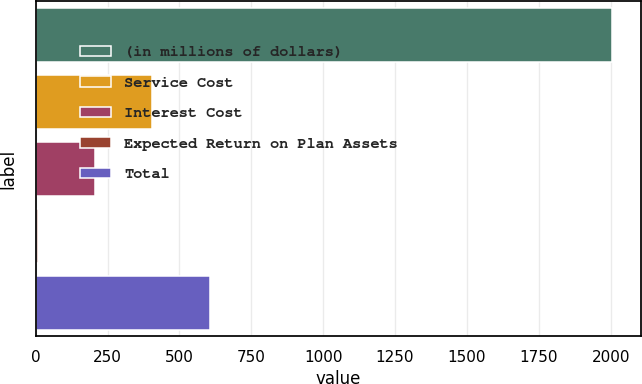Convert chart to OTSL. <chart><loc_0><loc_0><loc_500><loc_500><bar_chart><fcel>(in millions of dollars)<fcel>Service Cost<fcel>Interest Cost<fcel>Expected Return on Plan Assets<fcel>Total<nl><fcel>2005<fcel>406.28<fcel>206.44<fcel>6.6<fcel>606.12<nl></chart> 